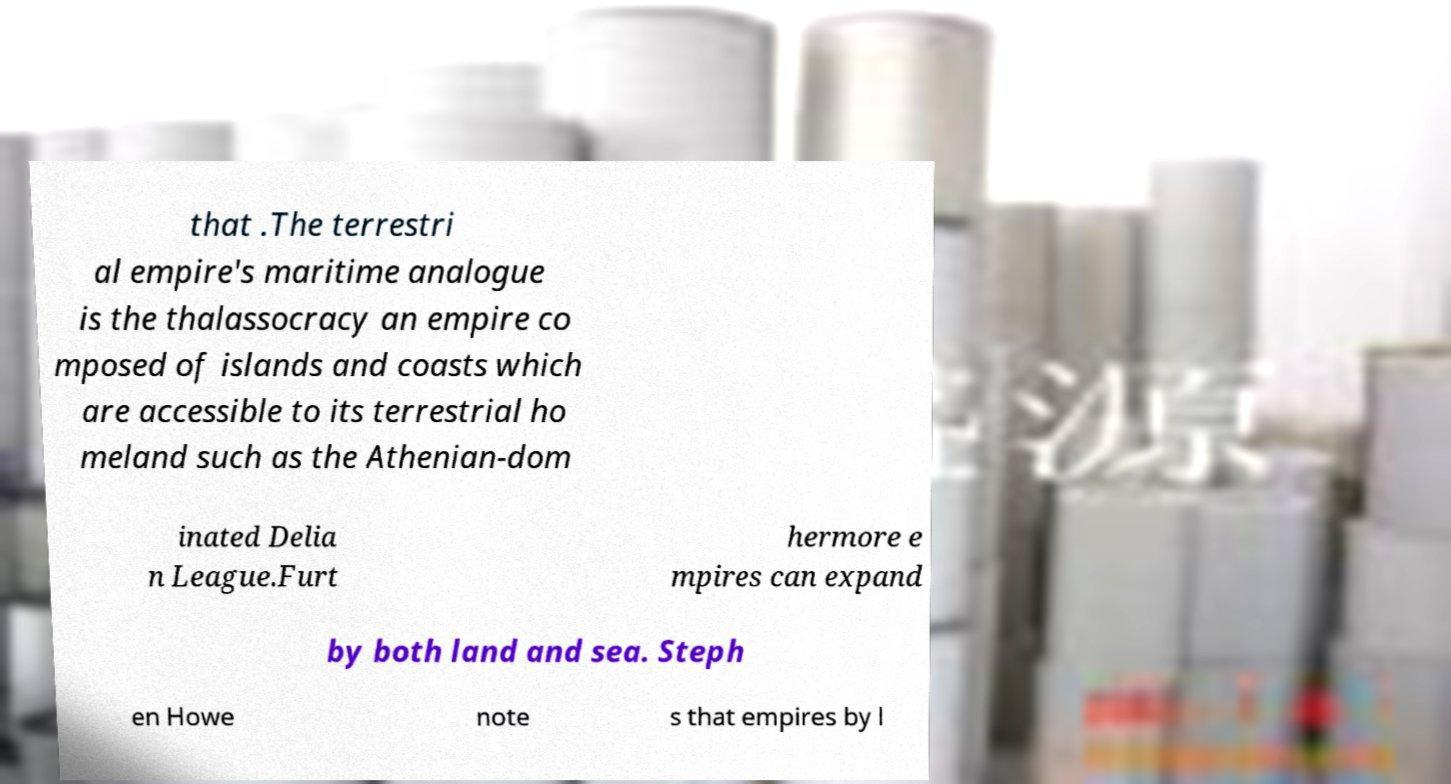What messages or text are displayed in this image? I need them in a readable, typed format. that .The terrestri al empire's maritime analogue is the thalassocracy an empire co mposed of islands and coasts which are accessible to its terrestrial ho meland such as the Athenian-dom inated Delia n League.Furt hermore e mpires can expand by both land and sea. Steph en Howe note s that empires by l 